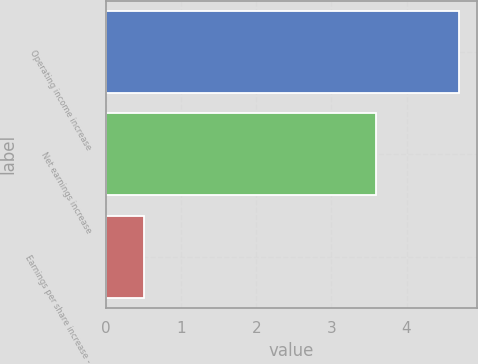Convert chart. <chart><loc_0><loc_0><loc_500><loc_500><bar_chart><fcel>Operating income increase<fcel>Net earnings increase<fcel>Earnings per share increase -<nl><fcel>4.7<fcel>3.6<fcel>0.5<nl></chart> 